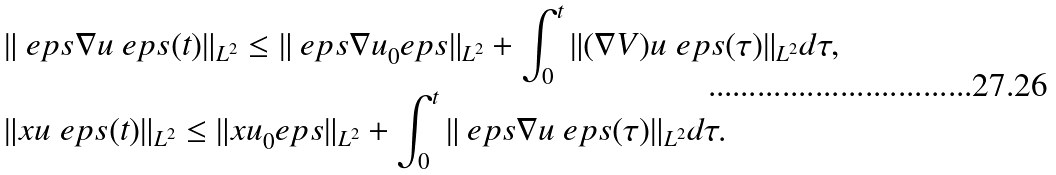<formula> <loc_0><loc_0><loc_500><loc_500>& \| \ e p s \nabla u ^ { \ } e p s ( t ) \| _ { L ^ { 2 } } \leq \| \ e p s \nabla u _ { 0 } ^ { \ } e p s \| _ { L ^ { 2 } } + \int _ { 0 } ^ { t } \| ( \nabla V ) u ^ { \ } e p s ( \tau ) \| _ { L ^ { 2 } } d \tau , \\ & \| x u ^ { \ } e p s ( t ) \| _ { L ^ { 2 } } \leq \| x u _ { 0 } ^ { \ } e p s \| _ { L ^ { 2 } } + \int _ { 0 } ^ { t } \| \ e p s \nabla u ^ { \ } e p s ( \tau ) \| _ { L ^ { 2 } } d \tau .</formula> 